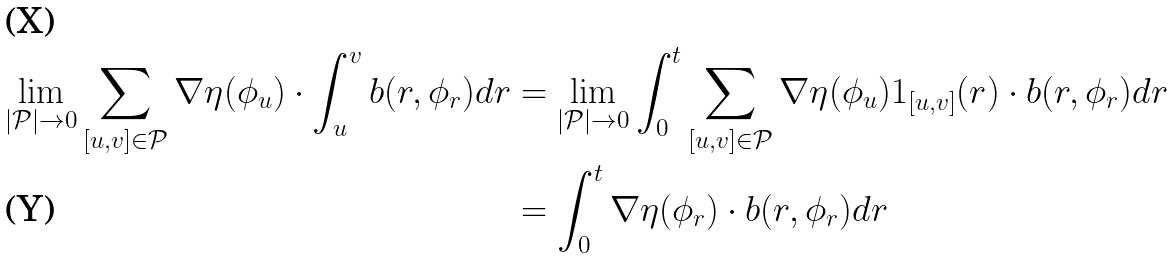Convert formula to latex. <formula><loc_0><loc_0><loc_500><loc_500>\lim _ { | \mathcal { P } | \rightarrow 0 } \sum _ { [ u , v ] \in \mathcal { P } } \nabla \eta ( \phi _ { u } ) \cdot \int _ { u } ^ { v } b ( r , \phi _ { r } ) d r & = \lim _ { | \mathcal { P } | \rightarrow 0 } \int _ { 0 } ^ { t } \sum _ { [ u , v ] \in \mathcal { P } } \nabla \eta ( \phi _ { u } ) 1 _ { [ u , v ] } ( r ) \cdot b ( r , \phi _ { r } ) d r \\ & = \int _ { 0 } ^ { t } \nabla \eta ( \phi _ { r } ) \cdot b ( r , \phi _ { r } ) d r</formula> 